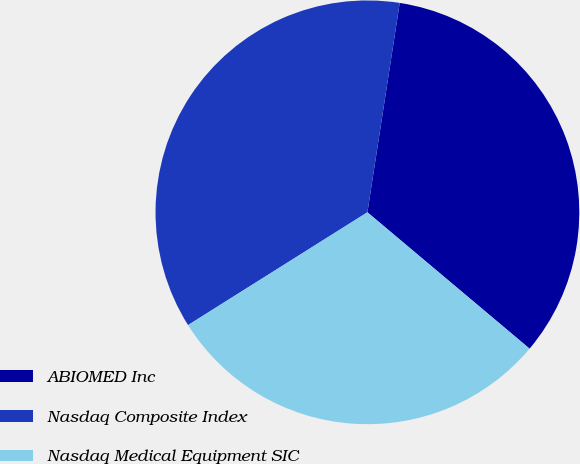Convert chart to OTSL. <chart><loc_0><loc_0><loc_500><loc_500><pie_chart><fcel>ABIOMED Inc<fcel>Nasdaq Composite Index<fcel>Nasdaq Medical Equipment SIC<nl><fcel>33.69%<fcel>36.37%<fcel>29.94%<nl></chart> 